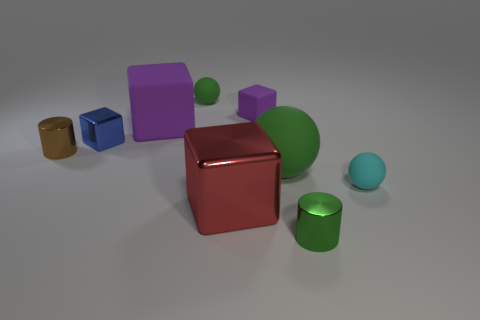There is a tiny cylinder that is on the right side of the metal block left of the red block; what is its material? The tiny cylinder situated to the right of the metallic block and to the left of the red block appears to be made of metal, similar to the larger block beside it, showcasing a reflective surface indicative of metallic materials. 